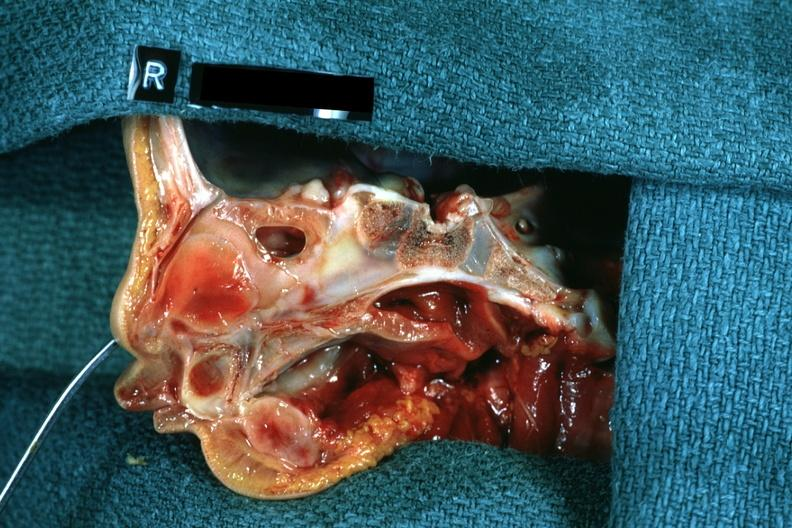s outside adrenal capsule section left was patent hemisection of nose?
Answer the question using a single word or phrase. No 